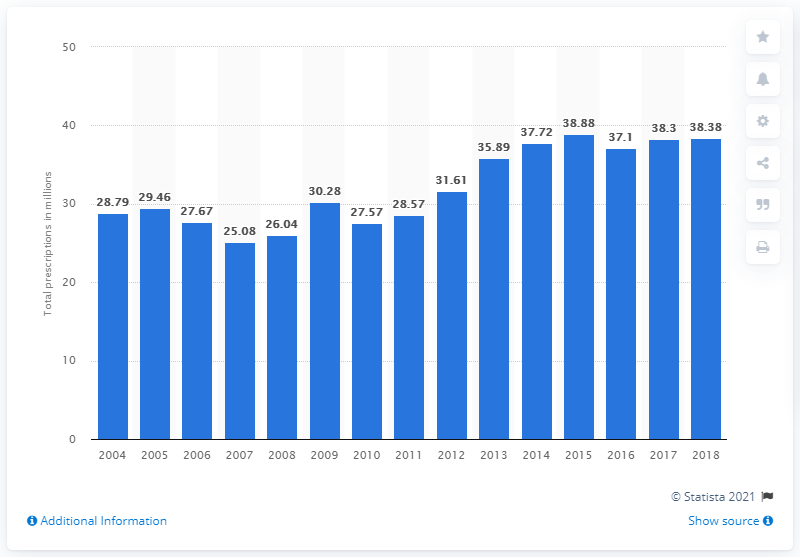Outline some significant characteristics in this image. In 2017, there were 37.72 prescriptions for sertraline hydrochloride. 